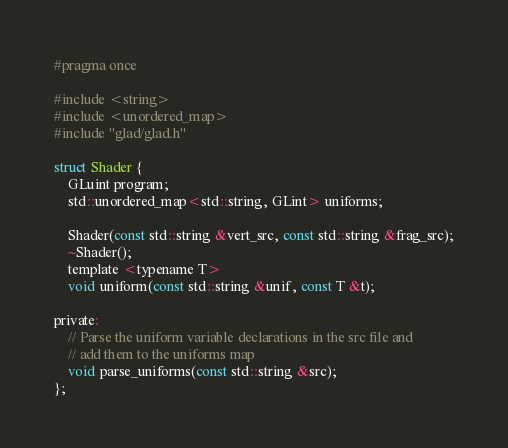<code> <loc_0><loc_0><loc_500><loc_500><_C_>#pragma once

#include <string>
#include <unordered_map>
#include "glad/glad.h"

struct Shader {
    GLuint program;
    std::unordered_map<std::string, GLint> uniforms;

    Shader(const std::string &vert_src, const std::string &frag_src);
    ~Shader();
    template <typename T>
    void uniform(const std::string &unif, const T &t);

private:
    // Parse the uniform variable declarations in the src file and
    // add them to the uniforms map
    void parse_uniforms(const std::string &src);
};
</code> 